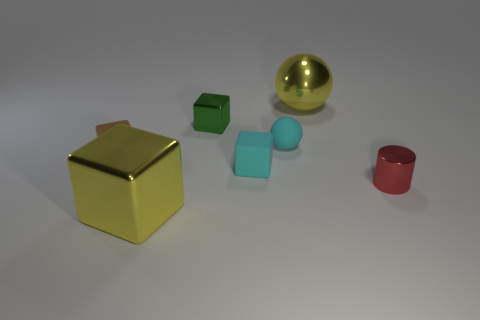Subtract all tiny green blocks. How many blocks are left? 3 Add 1 small brown matte objects. How many objects exist? 8 Subtract all cubes. How many objects are left? 3 Subtract 2 cubes. How many cubes are left? 2 Subtract all yellow blocks. How many blocks are left? 3 Subtract all gray balls. Subtract all purple blocks. How many balls are left? 2 Subtract all cyan things. Subtract all spheres. How many objects are left? 3 Add 3 red shiny cylinders. How many red shiny cylinders are left? 4 Add 3 balls. How many balls exist? 5 Subtract 0 green cylinders. How many objects are left? 7 